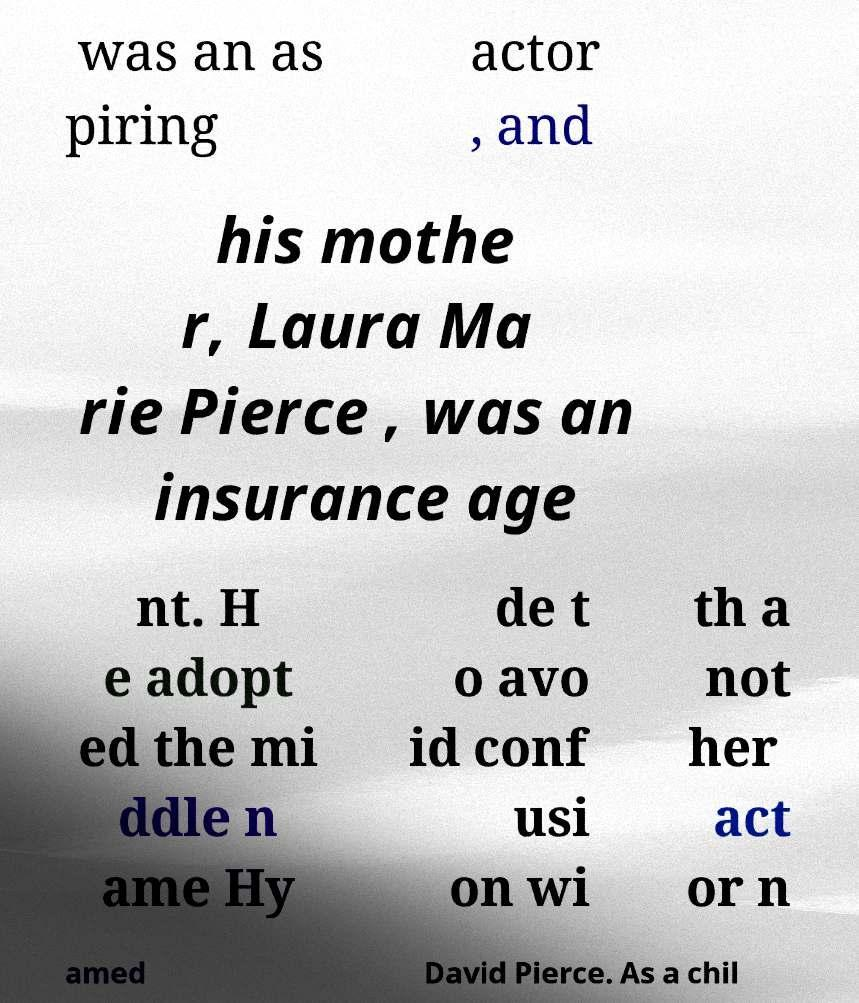Please read and relay the text visible in this image. What does it say? was an as piring actor , and his mothe r, Laura Ma rie Pierce , was an insurance age nt. H e adopt ed the mi ddle n ame Hy de t o avo id conf usi on wi th a not her act or n amed David Pierce. As a chil 